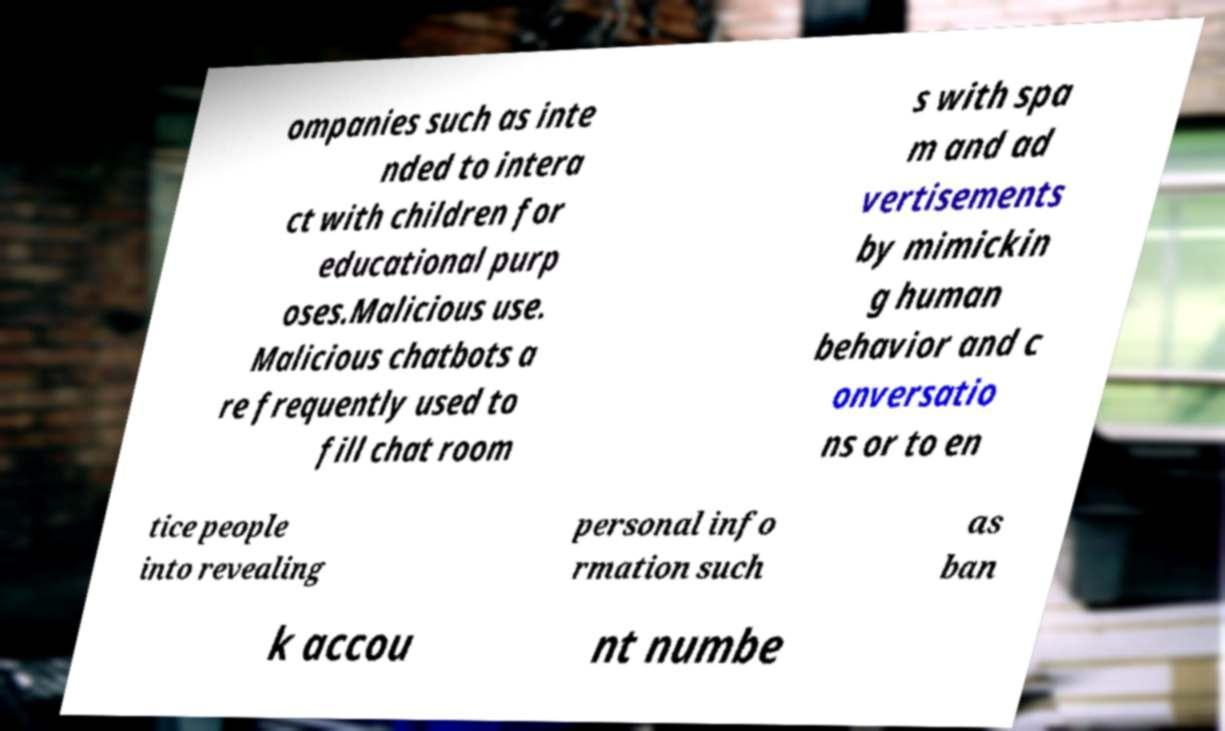Can you accurately transcribe the text from the provided image for me? ompanies such as inte nded to intera ct with children for educational purp oses.Malicious use. Malicious chatbots a re frequently used to fill chat room s with spa m and ad vertisements by mimickin g human behavior and c onversatio ns or to en tice people into revealing personal info rmation such as ban k accou nt numbe 